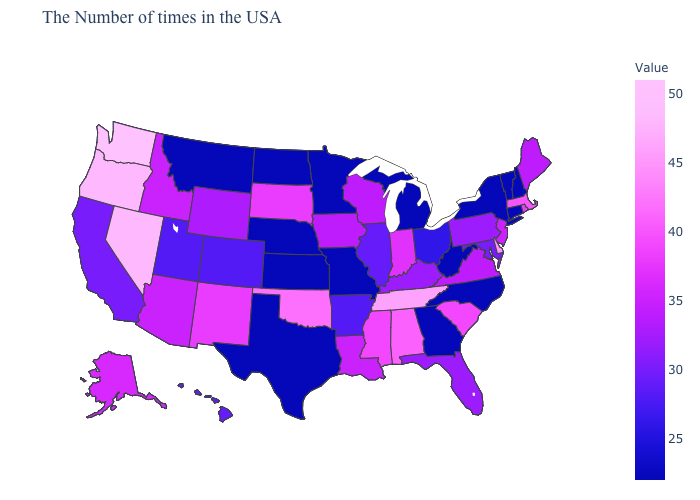Does Montana have the lowest value in the West?
Keep it brief. Yes. Is the legend a continuous bar?
Keep it brief. Yes. Does Connecticut have the lowest value in the USA?
Quick response, please. Yes. Which states have the lowest value in the West?
Give a very brief answer. Montana. Which states hav the highest value in the Northeast?
Answer briefly. Massachusetts. 